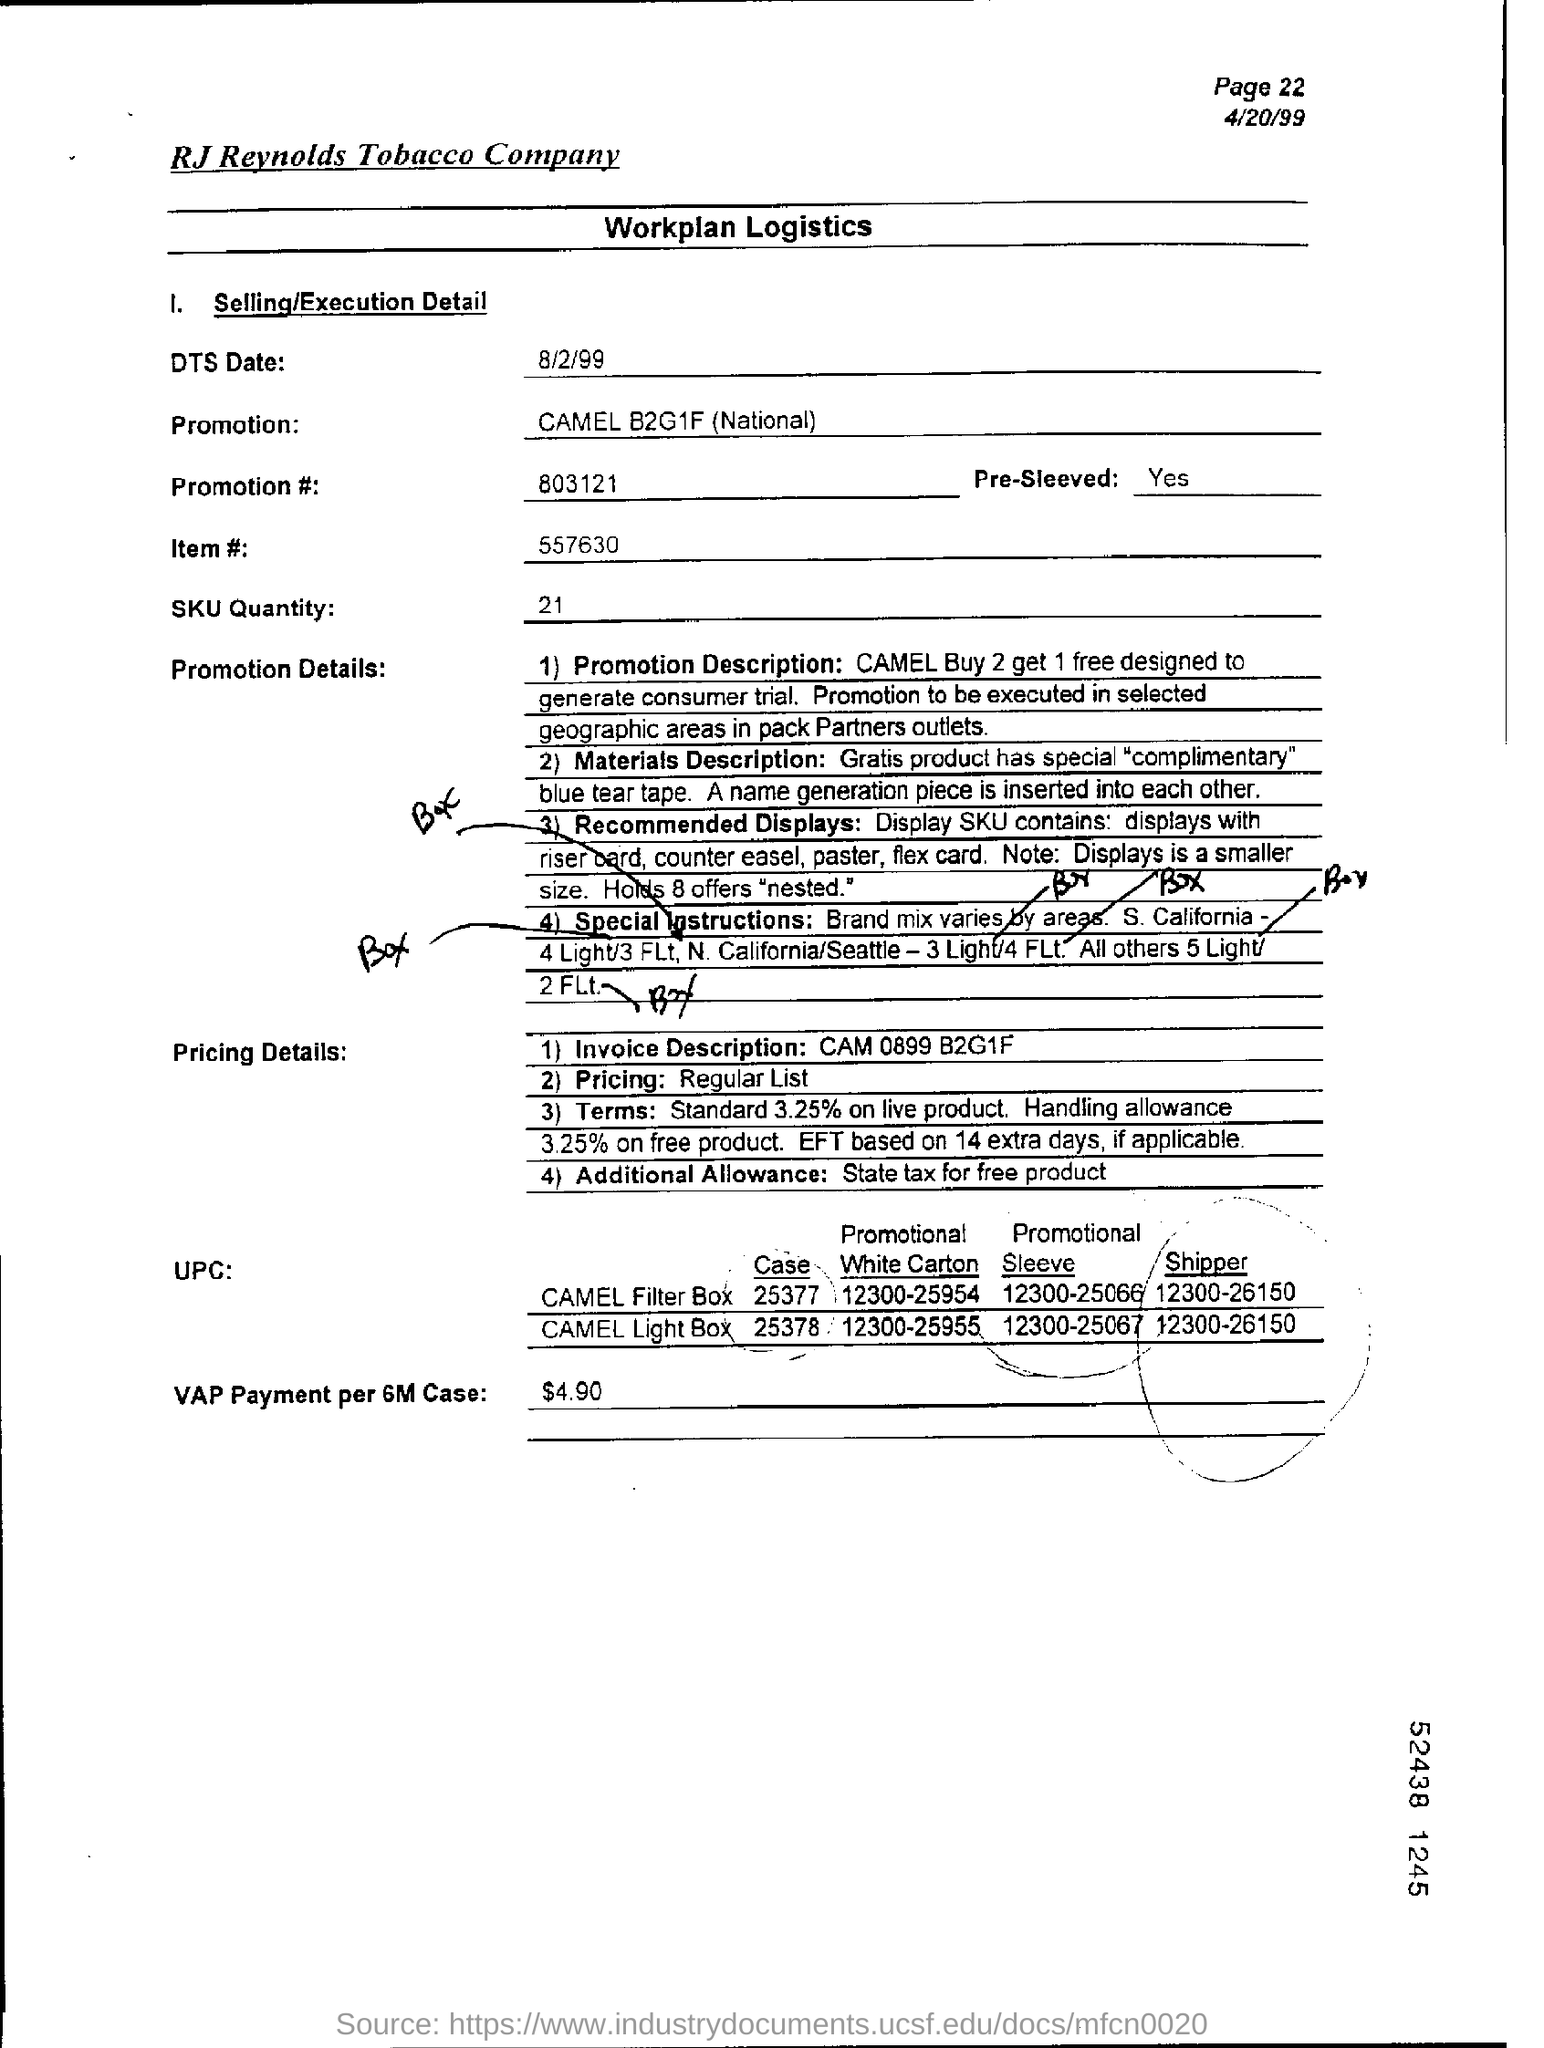Which company name is mentioned at the top of the page?
Provide a succinct answer. RJ Reynolds Tobacco Company. What is the "Promotion" item given under "Selling/Execution Detail" ?
Offer a terse response. CAMEL B2G1F (National). What is the Promotion number given under "Selling/Execution Detail" ?
Make the answer very short. 803121. Mention the ITEM number given?
Make the answer very short. 557630. What is the "SKU Quantity" given under "Selling/Execution Detail" ?
Provide a short and direct response. 21. What is the "Page" number given at the top right corner of the page?
Provide a short and direct response. Page 22. What is the "Date" given at the top right corner of the page?
Make the answer very short. 4/20/99. What is the "Invoice Description" mentioned under "Pricing Details"?
Offer a very short reply. CAM 0899 B2G1F. What is the "VAP Payment per 6M Case"?
Your answer should be compact. $4.90. 